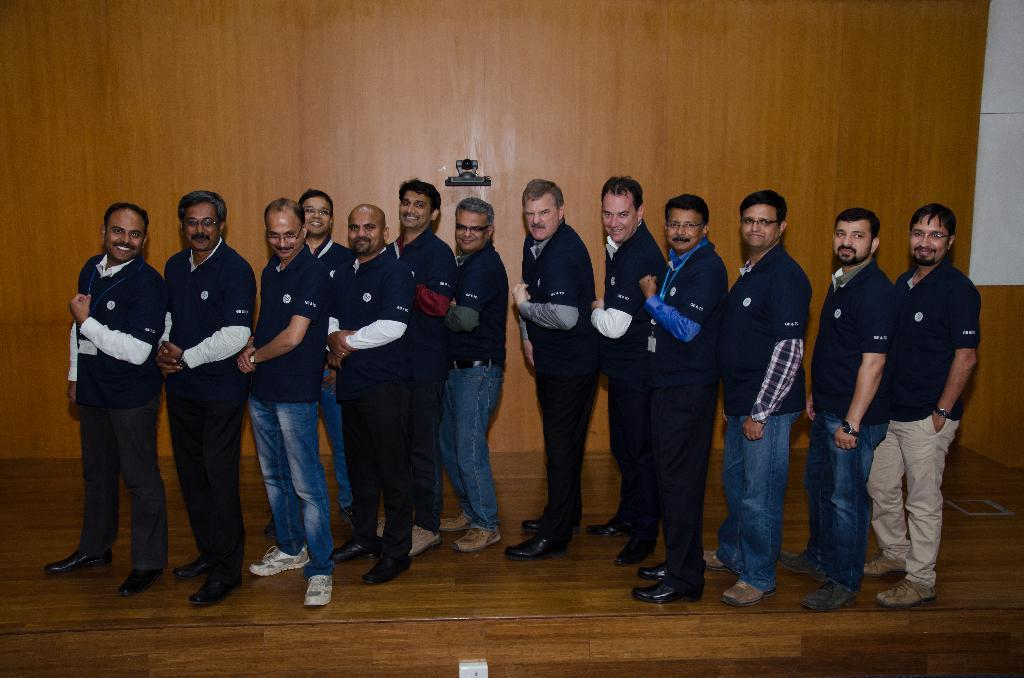How many people are in the foreground of the image? There are thirteen people in the foreground of the image. Where are the people standing in the image? The people are standing on a stage. Can you describe any objects or features at the bottom of the image? Yes, there is a switch at the bottom of the image. What thoughts are going through the knee of the person in the center of the image? There is no information about the thoughts of the people in the image, nor is there any indication that a person's knee is capable of thinking. 